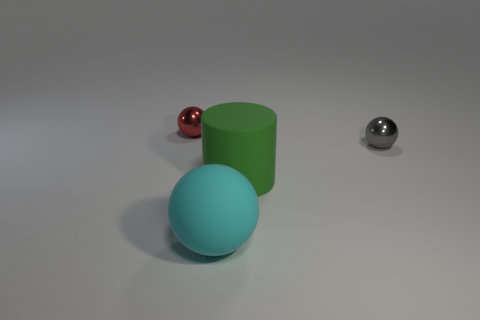Subtract all rubber balls. How many balls are left? 2 Subtract all cyan spheres. How many spheres are left? 2 Add 4 blue shiny cubes. How many objects exist? 8 Subtract all cylinders. How many objects are left? 3 Subtract 1 cylinders. How many cylinders are left? 0 Add 3 big cylinders. How many big cylinders are left? 4 Add 3 red metallic blocks. How many red metallic blocks exist? 3 Subtract 0 blue blocks. How many objects are left? 4 Subtract all purple spheres. Subtract all red blocks. How many spheres are left? 3 Subtract all brown cubes. How many gray spheres are left? 1 